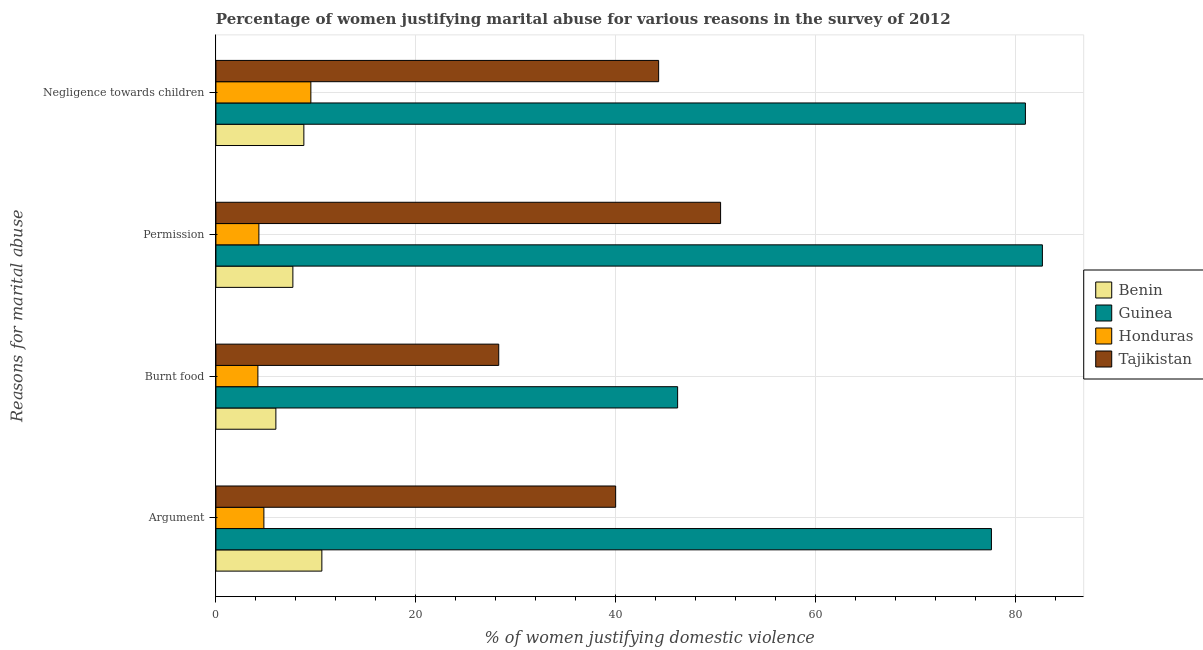How many different coloured bars are there?
Keep it short and to the point. 4. How many groups of bars are there?
Offer a terse response. 4. What is the label of the 2nd group of bars from the top?
Provide a short and direct response. Permission. What is the percentage of women justifying abuse in the case of an argument in Honduras?
Give a very brief answer. 4.8. Across all countries, what is the maximum percentage of women justifying abuse for going without permission?
Offer a terse response. 82.7. Across all countries, what is the minimum percentage of women justifying abuse in the case of an argument?
Provide a succinct answer. 4.8. In which country was the percentage of women justifying abuse for going without permission maximum?
Provide a succinct answer. Guinea. In which country was the percentage of women justifying abuse in the case of an argument minimum?
Provide a short and direct response. Honduras. What is the total percentage of women justifying abuse for going without permission in the graph?
Your response must be concise. 145.2. What is the difference between the percentage of women justifying abuse for going without permission in Tajikistan and that in Honduras?
Make the answer very short. 46.2. What is the difference between the percentage of women justifying abuse in the case of an argument in Guinea and the percentage of women justifying abuse for burning food in Tajikistan?
Your response must be concise. 49.3. What is the average percentage of women justifying abuse for going without permission per country?
Give a very brief answer. 36.3. What is the difference between the percentage of women justifying abuse in the case of an argument and percentage of women justifying abuse for going without permission in Benin?
Your answer should be compact. 2.9. In how many countries, is the percentage of women justifying abuse for showing negligence towards children greater than 28 %?
Offer a very short reply. 2. What is the ratio of the percentage of women justifying abuse for burning food in Tajikistan to that in Honduras?
Ensure brevity in your answer.  6.74. Is the difference between the percentage of women justifying abuse for going without permission in Benin and Guinea greater than the difference between the percentage of women justifying abuse in the case of an argument in Benin and Guinea?
Ensure brevity in your answer.  No. What is the difference between the highest and the second highest percentage of women justifying abuse in the case of an argument?
Give a very brief answer. 37.6. What is the difference between the highest and the lowest percentage of women justifying abuse for going without permission?
Your answer should be compact. 78.4. Is the sum of the percentage of women justifying abuse in the case of an argument in Honduras and Benin greater than the maximum percentage of women justifying abuse for going without permission across all countries?
Ensure brevity in your answer.  No. Is it the case that in every country, the sum of the percentage of women justifying abuse for showing negligence towards children and percentage of women justifying abuse for going without permission is greater than the sum of percentage of women justifying abuse for burning food and percentage of women justifying abuse in the case of an argument?
Ensure brevity in your answer.  No. What does the 3rd bar from the top in Permission represents?
Your response must be concise. Guinea. What does the 1st bar from the bottom in Burnt food represents?
Offer a terse response. Benin. Is it the case that in every country, the sum of the percentage of women justifying abuse in the case of an argument and percentage of women justifying abuse for burning food is greater than the percentage of women justifying abuse for going without permission?
Your answer should be compact. Yes. How many bars are there?
Your answer should be compact. 16. How many countries are there in the graph?
Offer a terse response. 4. What is the difference between two consecutive major ticks on the X-axis?
Make the answer very short. 20. What is the title of the graph?
Offer a terse response. Percentage of women justifying marital abuse for various reasons in the survey of 2012. Does "Uganda" appear as one of the legend labels in the graph?
Provide a succinct answer. No. What is the label or title of the X-axis?
Provide a succinct answer. % of women justifying domestic violence. What is the label or title of the Y-axis?
Your answer should be compact. Reasons for marital abuse. What is the % of women justifying domestic violence in Benin in Argument?
Ensure brevity in your answer.  10.6. What is the % of women justifying domestic violence in Guinea in Argument?
Give a very brief answer. 77.6. What is the % of women justifying domestic violence of Benin in Burnt food?
Keep it short and to the point. 6. What is the % of women justifying domestic violence in Guinea in Burnt food?
Make the answer very short. 46.2. What is the % of women justifying domestic violence of Tajikistan in Burnt food?
Provide a succinct answer. 28.3. What is the % of women justifying domestic violence in Guinea in Permission?
Your response must be concise. 82.7. What is the % of women justifying domestic violence of Honduras in Permission?
Your answer should be very brief. 4.3. What is the % of women justifying domestic violence of Tajikistan in Permission?
Ensure brevity in your answer.  50.5. What is the % of women justifying domestic violence in Honduras in Negligence towards children?
Provide a succinct answer. 9.5. What is the % of women justifying domestic violence of Tajikistan in Negligence towards children?
Keep it short and to the point. 44.3. Across all Reasons for marital abuse, what is the maximum % of women justifying domestic violence in Benin?
Provide a succinct answer. 10.6. Across all Reasons for marital abuse, what is the maximum % of women justifying domestic violence in Guinea?
Provide a succinct answer. 82.7. Across all Reasons for marital abuse, what is the maximum % of women justifying domestic violence of Honduras?
Ensure brevity in your answer.  9.5. Across all Reasons for marital abuse, what is the maximum % of women justifying domestic violence in Tajikistan?
Provide a short and direct response. 50.5. Across all Reasons for marital abuse, what is the minimum % of women justifying domestic violence of Guinea?
Your answer should be compact. 46.2. Across all Reasons for marital abuse, what is the minimum % of women justifying domestic violence of Tajikistan?
Keep it short and to the point. 28.3. What is the total % of women justifying domestic violence in Benin in the graph?
Your answer should be compact. 33.1. What is the total % of women justifying domestic violence of Guinea in the graph?
Offer a terse response. 287.5. What is the total % of women justifying domestic violence in Honduras in the graph?
Your answer should be compact. 22.8. What is the total % of women justifying domestic violence of Tajikistan in the graph?
Offer a terse response. 163.1. What is the difference between the % of women justifying domestic violence of Guinea in Argument and that in Burnt food?
Your response must be concise. 31.4. What is the difference between the % of women justifying domestic violence in Honduras in Argument and that in Burnt food?
Provide a succinct answer. 0.6. What is the difference between the % of women justifying domestic violence in Tajikistan in Argument and that in Burnt food?
Provide a short and direct response. 11.7. What is the difference between the % of women justifying domestic violence of Guinea in Argument and that in Permission?
Offer a terse response. -5.1. What is the difference between the % of women justifying domestic violence of Honduras in Argument and that in Permission?
Offer a very short reply. 0.5. What is the difference between the % of women justifying domestic violence in Tajikistan in Argument and that in Permission?
Ensure brevity in your answer.  -10.5. What is the difference between the % of women justifying domestic violence of Benin in Argument and that in Negligence towards children?
Your answer should be compact. 1.8. What is the difference between the % of women justifying domestic violence of Honduras in Argument and that in Negligence towards children?
Offer a very short reply. -4.7. What is the difference between the % of women justifying domestic violence in Tajikistan in Argument and that in Negligence towards children?
Your response must be concise. -4.3. What is the difference between the % of women justifying domestic violence of Benin in Burnt food and that in Permission?
Your answer should be very brief. -1.7. What is the difference between the % of women justifying domestic violence in Guinea in Burnt food and that in Permission?
Offer a terse response. -36.5. What is the difference between the % of women justifying domestic violence of Honduras in Burnt food and that in Permission?
Give a very brief answer. -0.1. What is the difference between the % of women justifying domestic violence in Tajikistan in Burnt food and that in Permission?
Give a very brief answer. -22.2. What is the difference between the % of women justifying domestic violence in Guinea in Burnt food and that in Negligence towards children?
Keep it short and to the point. -34.8. What is the difference between the % of women justifying domestic violence of Tajikistan in Permission and that in Negligence towards children?
Make the answer very short. 6.2. What is the difference between the % of women justifying domestic violence of Benin in Argument and the % of women justifying domestic violence of Guinea in Burnt food?
Give a very brief answer. -35.6. What is the difference between the % of women justifying domestic violence of Benin in Argument and the % of women justifying domestic violence of Honduras in Burnt food?
Make the answer very short. 6.4. What is the difference between the % of women justifying domestic violence of Benin in Argument and the % of women justifying domestic violence of Tajikistan in Burnt food?
Ensure brevity in your answer.  -17.7. What is the difference between the % of women justifying domestic violence of Guinea in Argument and the % of women justifying domestic violence of Honduras in Burnt food?
Keep it short and to the point. 73.4. What is the difference between the % of women justifying domestic violence of Guinea in Argument and the % of women justifying domestic violence of Tajikistan in Burnt food?
Make the answer very short. 49.3. What is the difference between the % of women justifying domestic violence of Honduras in Argument and the % of women justifying domestic violence of Tajikistan in Burnt food?
Give a very brief answer. -23.5. What is the difference between the % of women justifying domestic violence in Benin in Argument and the % of women justifying domestic violence in Guinea in Permission?
Keep it short and to the point. -72.1. What is the difference between the % of women justifying domestic violence of Benin in Argument and the % of women justifying domestic violence of Honduras in Permission?
Provide a short and direct response. 6.3. What is the difference between the % of women justifying domestic violence of Benin in Argument and the % of women justifying domestic violence of Tajikistan in Permission?
Your response must be concise. -39.9. What is the difference between the % of women justifying domestic violence of Guinea in Argument and the % of women justifying domestic violence of Honduras in Permission?
Your answer should be compact. 73.3. What is the difference between the % of women justifying domestic violence of Guinea in Argument and the % of women justifying domestic violence of Tajikistan in Permission?
Ensure brevity in your answer.  27.1. What is the difference between the % of women justifying domestic violence of Honduras in Argument and the % of women justifying domestic violence of Tajikistan in Permission?
Make the answer very short. -45.7. What is the difference between the % of women justifying domestic violence in Benin in Argument and the % of women justifying domestic violence in Guinea in Negligence towards children?
Offer a terse response. -70.4. What is the difference between the % of women justifying domestic violence of Benin in Argument and the % of women justifying domestic violence of Tajikistan in Negligence towards children?
Provide a succinct answer. -33.7. What is the difference between the % of women justifying domestic violence of Guinea in Argument and the % of women justifying domestic violence of Honduras in Negligence towards children?
Your response must be concise. 68.1. What is the difference between the % of women justifying domestic violence of Guinea in Argument and the % of women justifying domestic violence of Tajikistan in Negligence towards children?
Offer a very short reply. 33.3. What is the difference between the % of women justifying domestic violence of Honduras in Argument and the % of women justifying domestic violence of Tajikistan in Negligence towards children?
Offer a very short reply. -39.5. What is the difference between the % of women justifying domestic violence in Benin in Burnt food and the % of women justifying domestic violence in Guinea in Permission?
Keep it short and to the point. -76.7. What is the difference between the % of women justifying domestic violence in Benin in Burnt food and the % of women justifying domestic violence in Tajikistan in Permission?
Provide a short and direct response. -44.5. What is the difference between the % of women justifying domestic violence of Guinea in Burnt food and the % of women justifying domestic violence of Honduras in Permission?
Ensure brevity in your answer.  41.9. What is the difference between the % of women justifying domestic violence in Guinea in Burnt food and the % of women justifying domestic violence in Tajikistan in Permission?
Provide a short and direct response. -4.3. What is the difference between the % of women justifying domestic violence in Honduras in Burnt food and the % of women justifying domestic violence in Tajikistan in Permission?
Make the answer very short. -46.3. What is the difference between the % of women justifying domestic violence in Benin in Burnt food and the % of women justifying domestic violence in Guinea in Negligence towards children?
Make the answer very short. -75. What is the difference between the % of women justifying domestic violence in Benin in Burnt food and the % of women justifying domestic violence in Honduras in Negligence towards children?
Provide a short and direct response. -3.5. What is the difference between the % of women justifying domestic violence in Benin in Burnt food and the % of women justifying domestic violence in Tajikistan in Negligence towards children?
Your answer should be very brief. -38.3. What is the difference between the % of women justifying domestic violence in Guinea in Burnt food and the % of women justifying domestic violence in Honduras in Negligence towards children?
Make the answer very short. 36.7. What is the difference between the % of women justifying domestic violence of Guinea in Burnt food and the % of women justifying domestic violence of Tajikistan in Negligence towards children?
Offer a very short reply. 1.9. What is the difference between the % of women justifying domestic violence in Honduras in Burnt food and the % of women justifying domestic violence in Tajikistan in Negligence towards children?
Ensure brevity in your answer.  -40.1. What is the difference between the % of women justifying domestic violence in Benin in Permission and the % of women justifying domestic violence in Guinea in Negligence towards children?
Your answer should be very brief. -73.3. What is the difference between the % of women justifying domestic violence of Benin in Permission and the % of women justifying domestic violence of Honduras in Negligence towards children?
Provide a succinct answer. -1.8. What is the difference between the % of women justifying domestic violence of Benin in Permission and the % of women justifying domestic violence of Tajikistan in Negligence towards children?
Your answer should be very brief. -36.6. What is the difference between the % of women justifying domestic violence of Guinea in Permission and the % of women justifying domestic violence of Honduras in Negligence towards children?
Offer a very short reply. 73.2. What is the difference between the % of women justifying domestic violence of Guinea in Permission and the % of women justifying domestic violence of Tajikistan in Negligence towards children?
Provide a short and direct response. 38.4. What is the average % of women justifying domestic violence of Benin per Reasons for marital abuse?
Provide a succinct answer. 8.28. What is the average % of women justifying domestic violence in Guinea per Reasons for marital abuse?
Keep it short and to the point. 71.88. What is the average % of women justifying domestic violence of Honduras per Reasons for marital abuse?
Keep it short and to the point. 5.7. What is the average % of women justifying domestic violence in Tajikistan per Reasons for marital abuse?
Your response must be concise. 40.77. What is the difference between the % of women justifying domestic violence of Benin and % of women justifying domestic violence of Guinea in Argument?
Keep it short and to the point. -67. What is the difference between the % of women justifying domestic violence of Benin and % of women justifying domestic violence of Honduras in Argument?
Make the answer very short. 5.8. What is the difference between the % of women justifying domestic violence of Benin and % of women justifying domestic violence of Tajikistan in Argument?
Make the answer very short. -29.4. What is the difference between the % of women justifying domestic violence in Guinea and % of women justifying domestic violence in Honduras in Argument?
Your answer should be compact. 72.8. What is the difference between the % of women justifying domestic violence in Guinea and % of women justifying domestic violence in Tajikistan in Argument?
Your answer should be compact. 37.6. What is the difference between the % of women justifying domestic violence of Honduras and % of women justifying domestic violence of Tajikistan in Argument?
Your answer should be compact. -35.2. What is the difference between the % of women justifying domestic violence of Benin and % of women justifying domestic violence of Guinea in Burnt food?
Provide a succinct answer. -40.2. What is the difference between the % of women justifying domestic violence in Benin and % of women justifying domestic violence in Honduras in Burnt food?
Make the answer very short. 1.8. What is the difference between the % of women justifying domestic violence of Benin and % of women justifying domestic violence of Tajikistan in Burnt food?
Your response must be concise. -22.3. What is the difference between the % of women justifying domestic violence in Guinea and % of women justifying domestic violence in Tajikistan in Burnt food?
Keep it short and to the point. 17.9. What is the difference between the % of women justifying domestic violence of Honduras and % of women justifying domestic violence of Tajikistan in Burnt food?
Give a very brief answer. -24.1. What is the difference between the % of women justifying domestic violence of Benin and % of women justifying domestic violence of Guinea in Permission?
Ensure brevity in your answer.  -75. What is the difference between the % of women justifying domestic violence of Benin and % of women justifying domestic violence of Honduras in Permission?
Your answer should be very brief. 3.4. What is the difference between the % of women justifying domestic violence of Benin and % of women justifying domestic violence of Tajikistan in Permission?
Your answer should be compact. -42.8. What is the difference between the % of women justifying domestic violence of Guinea and % of women justifying domestic violence of Honduras in Permission?
Offer a terse response. 78.4. What is the difference between the % of women justifying domestic violence of Guinea and % of women justifying domestic violence of Tajikistan in Permission?
Provide a succinct answer. 32.2. What is the difference between the % of women justifying domestic violence of Honduras and % of women justifying domestic violence of Tajikistan in Permission?
Provide a short and direct response. -46.2. What is the difference between the % of women justifying domestic violence in Benin and % of women justifying domestic violence in Guinea in Negligence towards children?
Keep it short and to the point. -72.2. What is the difference between the % of women justifying domestic violence of Benin and % of women justifying domestic violence of Tajikistan in Negligence towards children?
Offer a terse response. -35.5. What is the difference between the % of women justifying domestic violence of Guinea and % of women justifying domestic violence of Honduras in Negligence towards children?
Your response must be concise. 71.5. What is the difference between the % of women justifying domestic violence of Guinea and % of women justifying domestic violence of Tajikistan in Negligence towards children?
Offer a very short reply. 36.7. What is the difference between the % of women justifying domestic violence in Honduras and % of women justifying domestic violence in Tajikistan in Negligence towards children?
Your answer should be very brief. -34.8. What is the ratio of the % of women justifying domestic violence in Benin in Argument to that in Burnt food?
Offer a terse response. 1.77. What is the ratio of the % of women justifying domestic violence in Guinea in Argument to that in Burnt food?
Provide a short and direct response. 1.68. What is the ratio of the % of women justifying domestic violence in Honduras in Argument to that in Burnt food?
Offer a terse response. 1.14. What is the ratio of the % of women justifying domestic violence of Tajikistan in Argument to that in Burnt food?
Offer a terse response. 1.41. What is the ratio of the % of women justifying domestic violence in Benin in Argument to that in Permission?
Offer a very short reply. 1.38. What is the ratio of the % of women justifying domestic violence of Guinea in Argument to that in Permission?
Make the answer very short. 0.94. What is the ratio of the % of women justifying domestic violence of Honduras in Argument to that in Permission?
Your answer should be very brief. 1.12. What is the ratio of the % of women justifying domestic violence in Tajikistan in Argument to that in Permission?
Your answer should be very brief. 0.79. What is the ratio of the % of women justifying domestic violence of Benin in Argument to that in Negligence towards children?
Keep it short and to the point. 1.2. What is the ratio of the % of women justifying domestic violence of Guinea in Argument to that in Negligence towards children?
Give a very brief answer. 0.96. What is the ratio of the % of women justifying domestic violence in Honduras in Argument to that in Negligence towards children?
Give a very brief answer. 0.51. What is the ratio of the % of women justifying domestic violence in Tajikistan in Argument to that in Negligence towards children?
Make the answer very short. 0.9. What is the ratio of the % of women justifying domestic violence of Benin in Burnt food to that in Permission?
Ensure brevity in your answer.  0.78. What is the ratio of the % of women justifying domestic violence of Guinea in Burnt food to that in Permission?
Provide a short and direct response. 0.56. What is the ratio of the % of women justifying domestic violence in Honduras in Burnt food to that in Permission?
Keep it short and to the point. 0.98. What is the ratio of the % of women justifying domestic violence of Tajikistan in Burnt food to that in Permission?
Provide a succinct answer. 0.56. What is the ratio of the % of women justifying domestic violence of Benin in Burnt food to that in Negligence towards children?
Keep it short and to the point. 0.68. What is the ratio of the % of women justifying domestic violence in Guinea in Burnt food to that in Negligence towards children?
Make the answer very short. 0.57. What is the ratio of the % of women justifying domestic violence of Honduras in Burnt food to that in Negligence towards children?
Your answer should be compact. 0.44. What is the ratio of the % of women justifying domestic violence in Tajikistan in Burnt food to that in Negligence towards children?
Provide a short and direct response. 0.64. What is the ratio of the % of women justifying domestic violence of Honduras in Permission to that in Negligence towards children?
Your response must be concise. 0.45. What is the ratio of the % of women justifying domestic violence of Tajikistan in Permission to that in Negligence towards children?
Your response must be concise. 1.14. What is the difference between the highest and the second highest % of women justifying domestic violence in Benin?
Your answer should be compact. 1.8. What is the difference between the highest and the second highest % of women justifying domestic violence in Guinea?
Offer a very short reply. 1.7. What is the difference between the highest and the second highest % of women justifying domestic violence of Honduras?
Offer a terse response. 4.7. What is the difference between the highest and the lowest % of women justifying domestic violence of Benin?
Ensure brevity in your answer.  4.6. What is the difference between the highest and the lowest % of women justifying domestic violence in Guinea?
Offer a terse response. 36.5. What is the difference between the highest and the lowest % of women justifying domestic violence of Honduras?
Your answer should be very brief. 5.3. What is the difference between the highest and the lowest % of women justifying domestic violence of Tajikistan?
Make the answer very short. 22.2. 